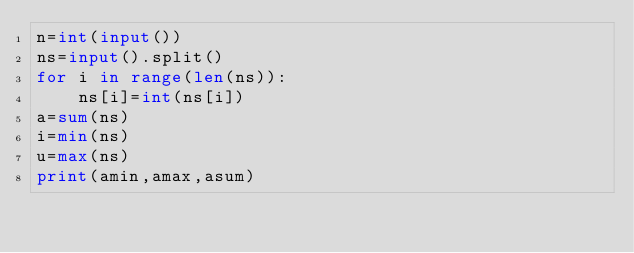Convert code to text. <code><loc_0><loc_0><loc_500><loc_500><_Python_>n=int(input())
ns=input().split()
for i in range(len(ns)):
    ns[i]=int(ns[i])
a=sum(ns)
i=min(ns)
u=max(ns)
print(amin,amax,asum)
</code> 